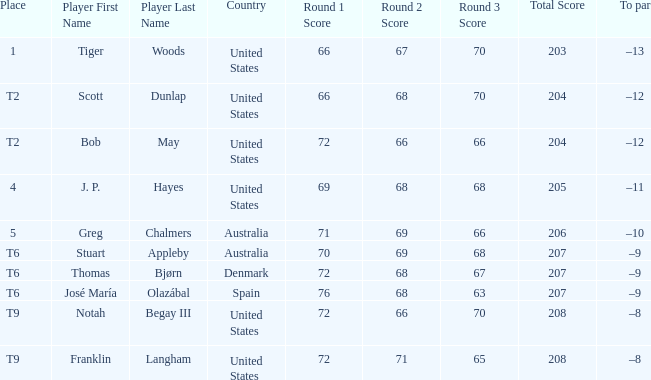What is the place of the player with a 72-71-65=208 score? T9. 